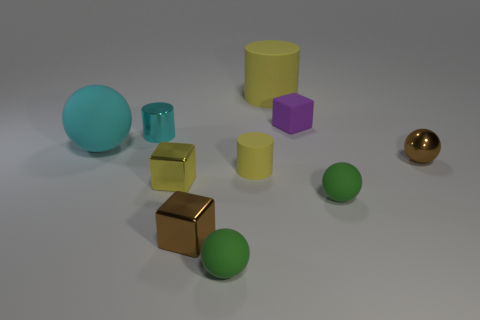What is the size of the cube that is the same color as the tiny metallic sphere?
Keep it short and to the point. Small. There is a brown object that is the same shape as the tiny yellow metal object; what size is it?
Your response must be concise. Small. There is a cyan object that is in front of the shiny cylinder; what material is it?
Your answer should be very brief. Rubber. How many large objects are green spheres or cyan cylinders?
Give a very brief answer. 0. Do the yellow matte object that is behind the purple matte object and the small yellow metallic cube have the same size?
Your response must be concise. No. How many other things are there of the same color as the large sphere?
Your answer should be very brief. 1. What material is the yellow block?
Your response must be concise. Metal. The ball that is to the right of the cyan ball and behind the yellow cube is made of what material?
Your answer should be very brief. Metal. How many objects are either small cylinders in front of the cyan cylinder or spheres?
Your answer should be compact. 5. Is the big rubber cylinder the same color as the tiny rubber cylinder?
Ensure brevity in your answer.  Yes. 